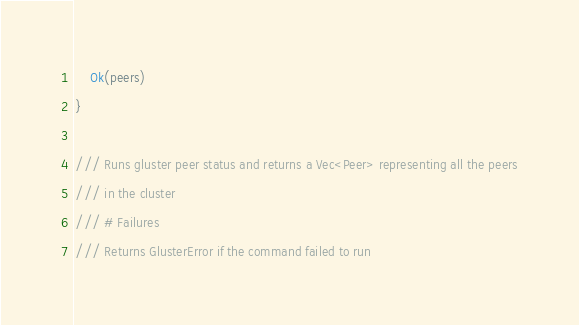<code> <loc_0><loc_0><loc_500><loc_500><_Rust_>    Ok(peers)
}

/// Runs gluster peer status and returns a Vec<Peer> representing all the peers
/// in the cluster
/// # Failures
/// Returns GlusterError if the command failed to run</code> 